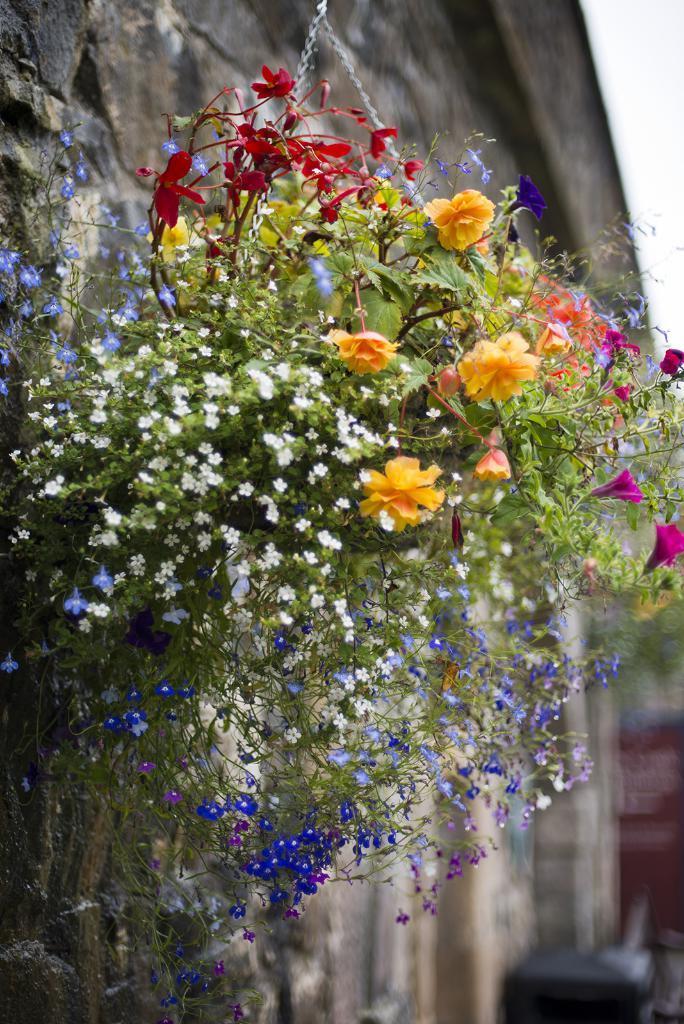Could you give a brief overview of what you see in this image? In this image we can see a potted plant with flowers, a wall and a blurry background. 